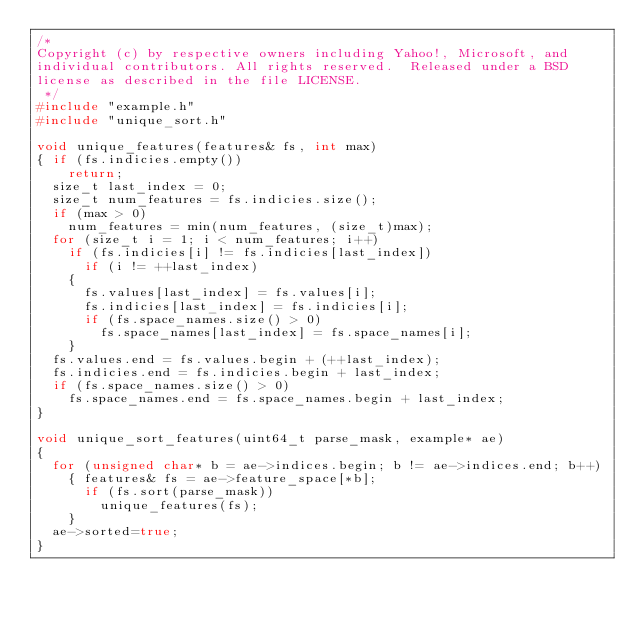<code> <loc_0><loc_0><loc_500><loc_500><_C++_>/*
Copyright (c) by respective owners including Yahoo!, Microsoft, and
individual contributors. All rights reserved.  Released under a BSD
license as described in the file LICENSE.
 */
#include "example.h"
#include "unique_sort.h"

void unique_features(features& fs, int max)
{ if (fs.indicies.empty())
    return;
  size_t last_index = 0;
  size_t num_features = fs.indicies.size();
  if (max > 0)
    num_features = min(num_features, (size_t)max);
  for (size_t i = 1; i < num_features; i++)
    if (fs.indicies[i] != fs.indicies[last_index])
      if (i != ++last_index)
	{
	  fs.values[last_index] = fs.values[i];
	  fs.indicies[last_index] = fs.indicies[i];
	  if (fs.space_names.size() > 0)
	    fs.space_names[last_index] = fs.space_names[i];
	}
  fs.values.end = fs.values.begin + (++last_index);
  fs.indicies.end = fs.indicies.begin + last_index;
  if (fs.space_names.size() > 0)
    fs.space_names.end = fs.space_names.begin + last_index;
}

void unique_sort_features(uint64_t parse_mask, example* ae)
{
  for (unsigned char* b = ae->indices.begin; b != ae->indices.end; b++)
    { features& fs = ae->feature_space[*b];
      if (fs.sort(parse_mask))
        unique_features(fs);
    }
  ae->sorted=true;
}
</code> 